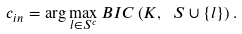<formula> <loc_0><loc_0><loc_500><loc_500>c _ { i n } = \arg \max _ { l \in S ^ { c } } B I C \left ( K , \ S \cup \left \{ l \right \} \right ) .</formula> 